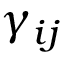<formula> <loc_0><loc_0><loc_500><loc_500>\gamma _ { i j }</formula> 